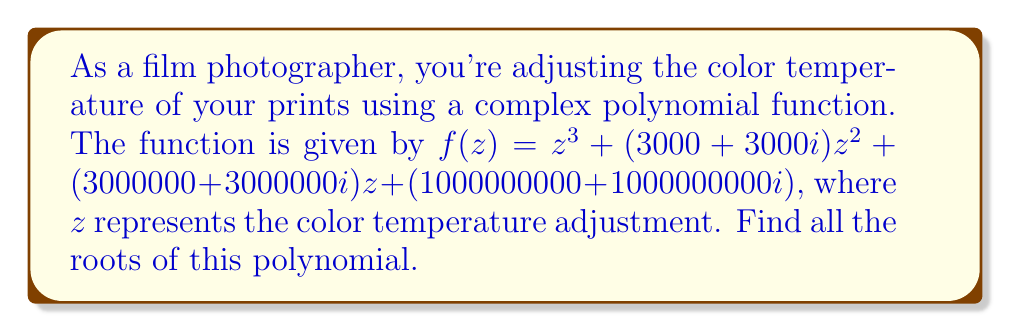Could you help me with this problem? To find the roots of this complex polynomial, we'll use the cubic formula. The general form of a cubic equation is $az^3 + bz^2 + cz + d = 0$.

In our case:
$a = 1$
$b = 3000 + 3000i$
$c = 3000000 + 3000000i$
$d = 1000000000 + 1000000000i$

Step 1: Calculate the discriminant
$p = \frac{3ac - b^2}{3a^2}$
$q = \frac{2b^3 - 9abc + 27a^2d}{27a^3}$

$p = \frac{3(1)(3000000 + 3000000i) - (3000 + 3000i)^2}{3(1)^2}$
$p = -1000000 - 1000000i$

$q = \frac{2(3000 + 3000i)^3 - 9(1)(3000000 + 3000000i)(3000 + 3000i) + 27(1)^2(1000000000 + 1000000000i)}{27(1)^3}$
$q = 0$

Step 2: Calculate the cube roots
$u = \sqrt[3]{-\frac{q}{2} + \sqrt{\frac{q^2}{4} + \frac{p^3}{27}}}$
$v = \sqrt[3]{-\frac{q}{2} - \sqrt{\frac{q^2}{4} + \frac{p^3}{27}}}$

$u = v = \sqrt[3]{1000000 + 1000000i}$

Step 3: Calculate the roots
$z_1 = u + v - \frac{b}{3a}$
$z_2 = -\frac{1}{2}(u + v) - \frac{b}{3a} + i\frac{\sqrt{3}}{2}(u - v)$
$z_3 = -\frac{1}{2}(u + v) - \frac{b}{3a} - i\frac{\sqrt{3}}{2}(u - v)$

$z_1 = 2\sqrt[3]{1000000 + 1000000i} - (1000 + 1000i)$
$z_2 = z_3 = -\sqrt[3]{1000000 + 1000000i} - (1000 + 1000i)$
Answer: $z_1 = 2\sqrt[3]{1000000 + 1000000i} - (1000 + 1000i)$, $z_2 = z_3 = -\sqrt[3]{1000000 + 1000000i} - (1000 + 1000i)$ 